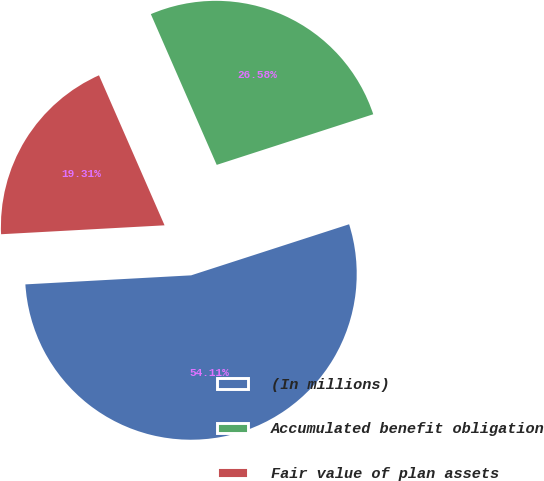Convert chart to OTSL. <chart><loc_0><loc_0><loc_500><loc_500><pie_chart><fcel>(In millions)<fcel>Accumulated benefit obligation<fcel>Fair value of plan assets<nl><fcel>54.11%<fcel>26.58%<fcel>19.31%<nl></chart> 